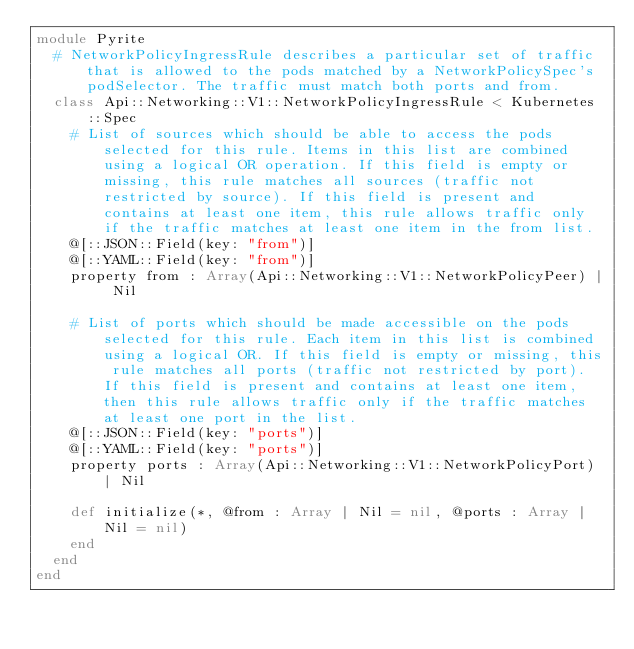Convert code to text. <code><loc_0><loc_0><loc_500><loc_500><_Crystal_>module Pyrite
  # NetworkPolicyIngressRule describes a particular set of traffic that is allowed to the pods matched by a NetworkPolicySpec's podSelector. The traffic must match both ports and from.
  class Api::Networking::V1::NetworkPolicyIngressRule < Kubernetes::Spec
    # List of sources which should be able to access the pods selected for this rule. Items in this list are combined using a logical OR operation. If this field is empty or missing, this rule matches all sources (traffic not restricted by source). If this field is present and contains at least one item, this rule allows traffic only if the traffic matches at least one item in the from list.
    @[::JSON::Field(key: "from")]
    @[::YAML::Field(key: "from")]
    property from : Array(Api::Networking::V1::NetworkPolicyPeer) | Nil

    # List of ports which should be made accessible on the pods selected for this rule. Each item in this list is combined using a logical OR. If this field is empty or missing, this rule matches all ports (traffic not restricted by port). If this field is present and contains at least one item, then this rule allows traffic only if the traffic matches at least one port in the list.
    @[::JSON::Field(key: "ports")]
    @[::YAML::Field(key: "ports")]
    property ports : Array(Api::Networking::V1::NetworkPolicyPort) | Nil

    def initialize(*, @from : Array | Nil = nil, @ports : Array | Nil = nil)
    end
  end
end
</code> 